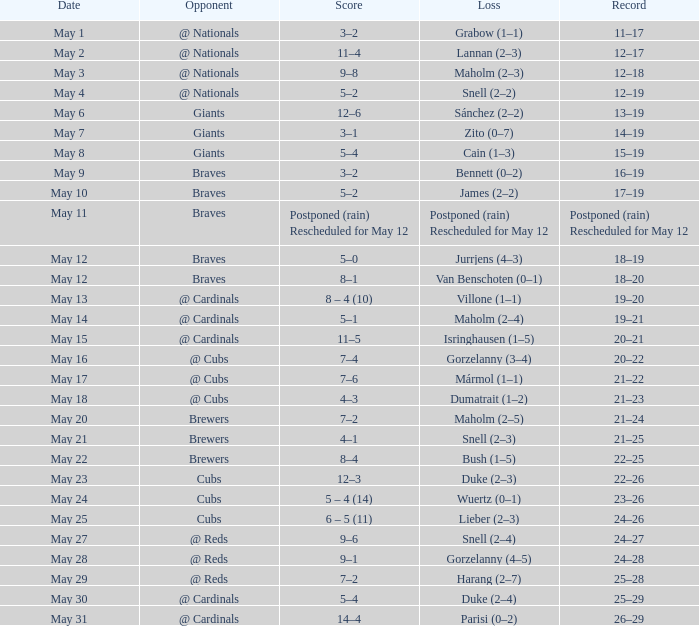What was the record of the game with a score of 12–6? 13–19. 